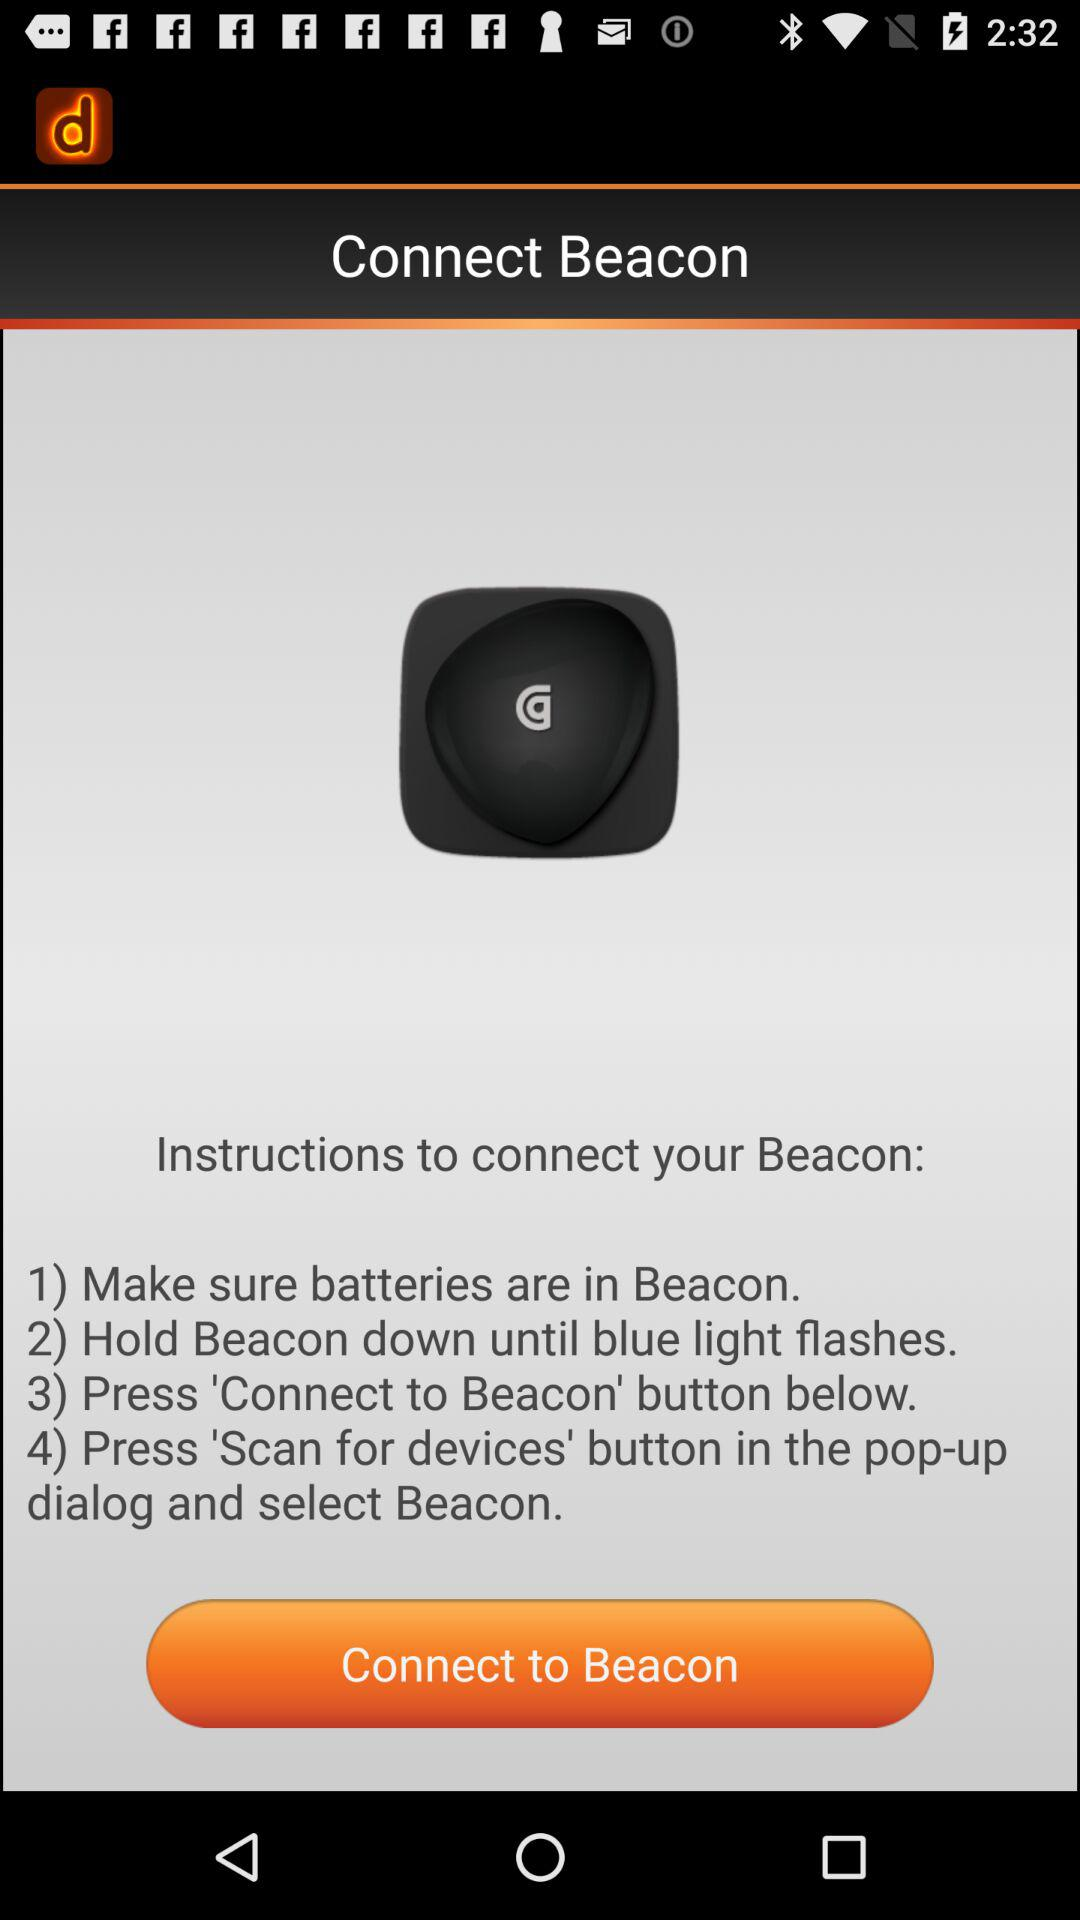How many steps are there in the instructions to connect to the beacon?
Answer the question using a single word or phrase. 4 